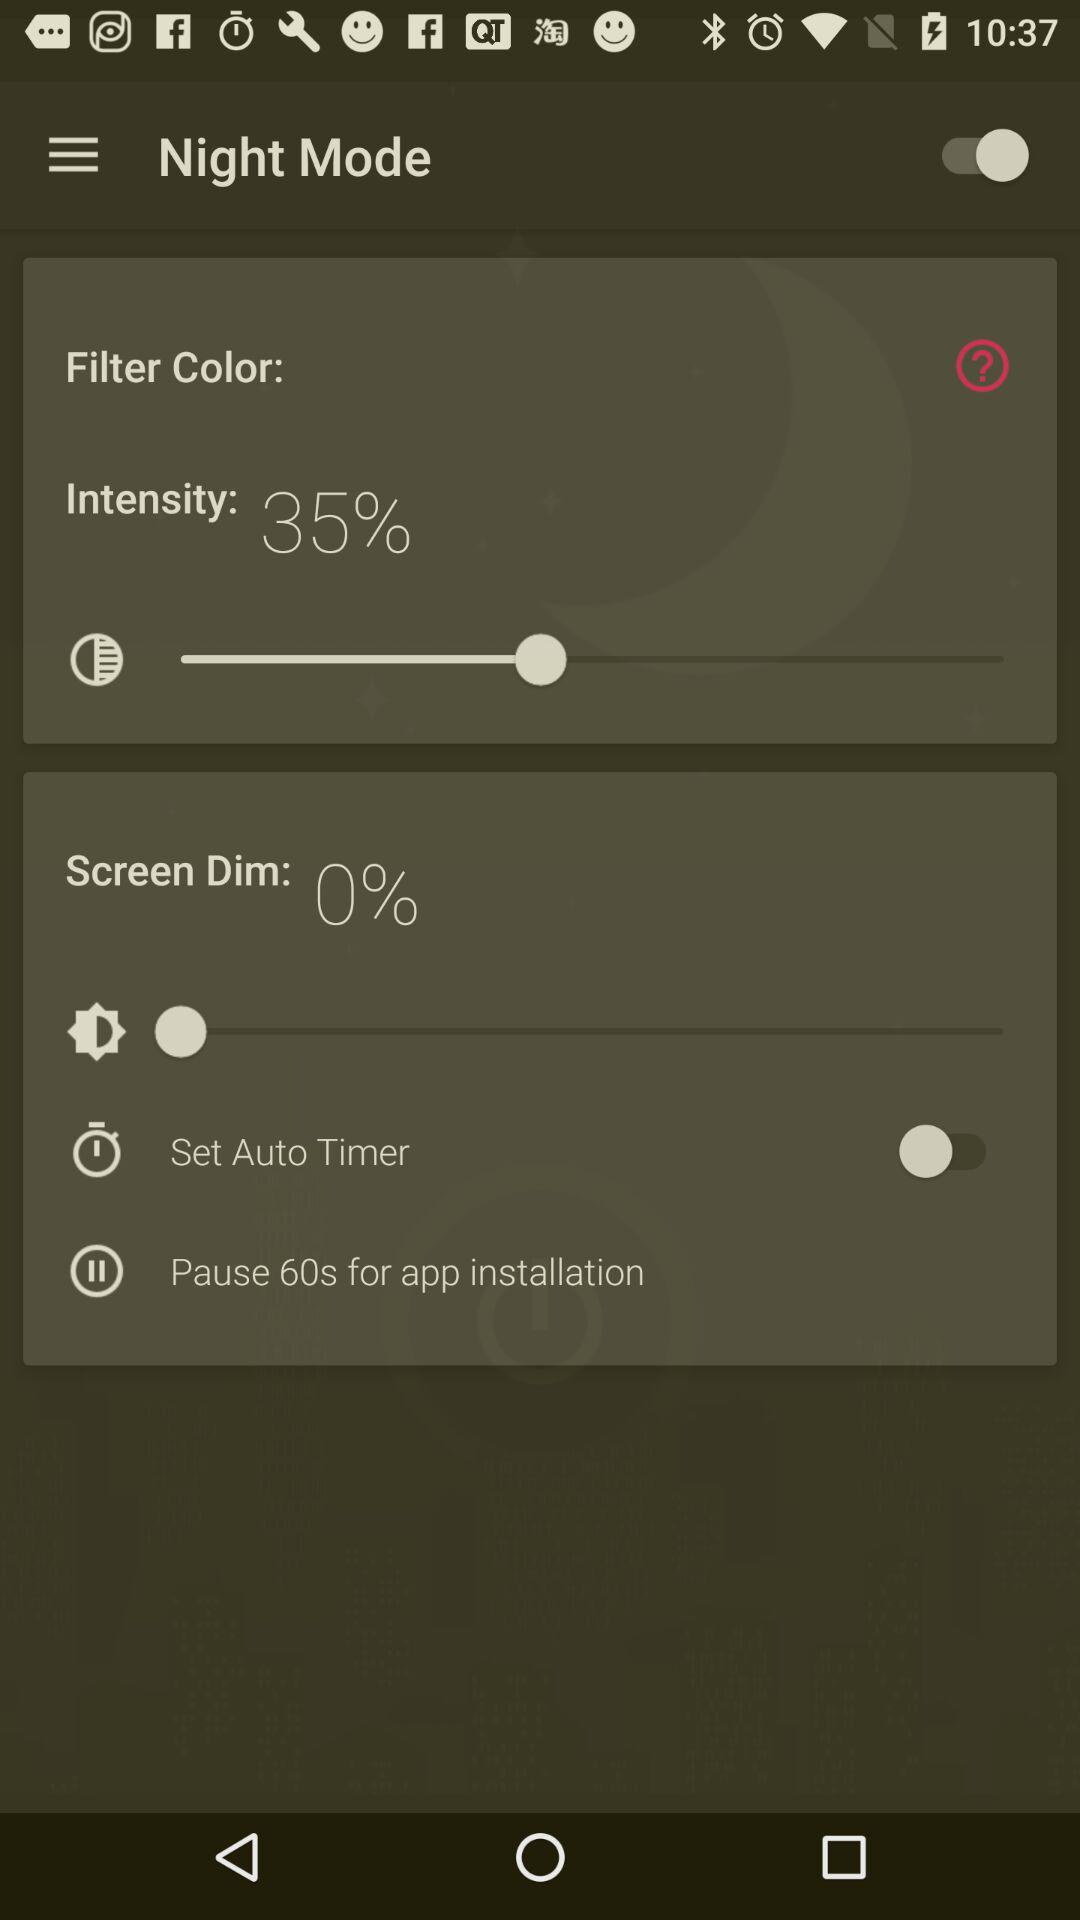By how much percentage is "Screen Dim"? The "Screen Dim" percentage is 0. 